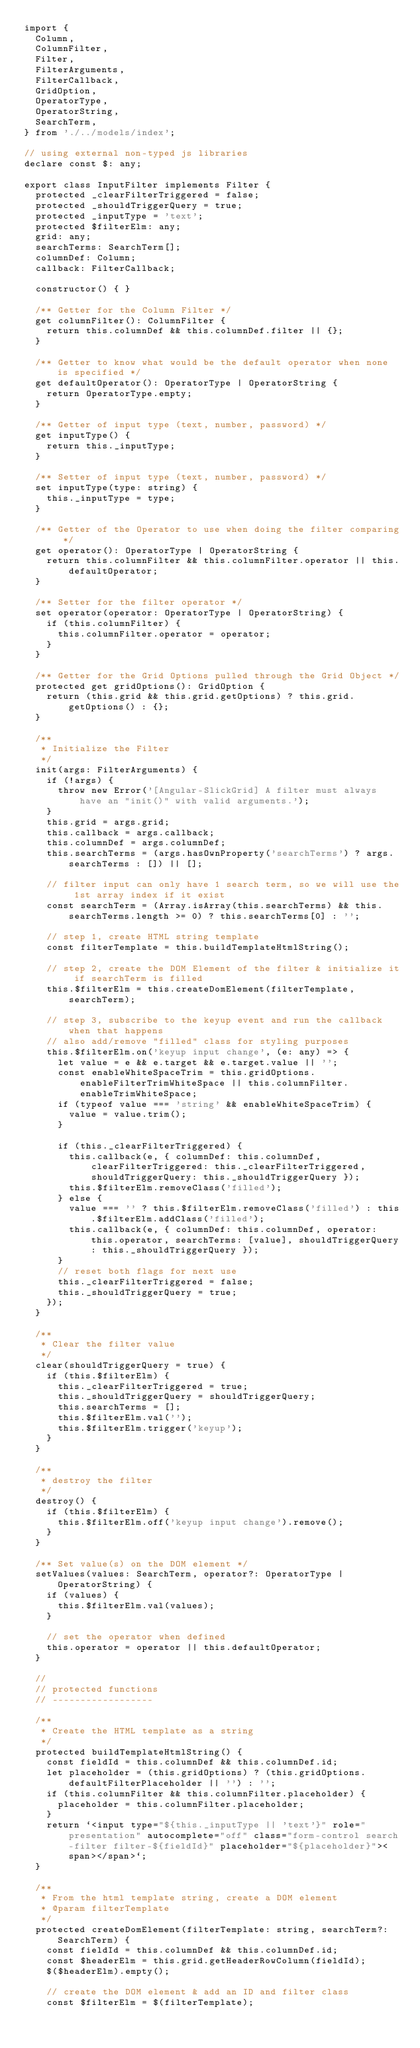<code> <loc_0><loc_0><loc_500><loc_500><_TypeScript_>import {
  Column,
  ColumnFilter,
  Filter,
  FilterArguments,
  FilterCallback,
  GridOption,
  OperatorType,
  OperatorString,
  SearchTerm,
} from './../models/index';

// using external non-typed js libraries
declare const $: any;

export class InputFilter implements Filter {
  protected _clearFilterTriggered = false;
  protected _shouldTriggerQuery = true;
  protected _inputType = 'text';
  protected $filterElm: any;
  grid: any;
  searchTerms: SearchTerm[];
  columnDef: Column;
  callback: FilterCallback;

  constructor() { }

  /** Getter for the Column Filter */
  get columnFilter(): ColumnFilter {
    return this.columnDef && this.columnDef.filter || {};
  }

  /** Getter to know what would be the default operator when none is specified */
  get defaultOperator(): OperatorType | OperatorString {
    return OperatorType.empty;
  }

  /** Getter of input type (text, number, password) */
  get inputType() {
    return this._inputType;
  }

  /** Setter of input type (text, number, password) */
  set inputType(type: string) {
    this._inputType = type;
  }

  /** Getter of the Operator to use when doing the filter comparing */
  get operator(): OperatorType | OperatorString {
    return this.columnFilter && this.columnFilter.operator || this.defaultOperator;
  }

  /** Setter for the filter operator */
  set operator(operator: OperatorType | OperatorString) {
    if (this.columnFilter) {
      this.columnFilter.operator = operator;
    }
  }

  /** Getter for the Grid Options pulled through the Grid Object */
  protected get gridOptions(): GridOption {
    return (this.grid && this.grid.getOptions) ? this.grid.getOptions() : {};
  }

  /**
   * Initialize the Filter
   */
  init(args: FilterArguments) {
    if (!args) {
      throw new Error('[Angular-SlickGrid] A filter must always have an "init()" with valid arguments.');
    }
    this.grid = args.grid;
    this.callback = args.callback;
    this.columnDef = args.columnDef;
    this.searchTerms = (args.hasOwnProperty('searchTerms') ? args.searchTerms : []) || [];

    // filter input can only have 1 search term, so we will use the 1st array index if it exist
    const searchTerm = (Array.isArray(this.searchTerms) && this.searchTerms.length >= 0) ? this.searchTerms[0] : '';

    // step 1, create HTML string template
    const filterTemplate = this.buildTemplateHtmlString();

    // step 2, create the DOM Element of the filter & initialize it if searchTerm is filled
    this.$filterElm = this.createDomElement(filterTemplate, searchTerm);

    // step 3, subscribe to the keyup event and run the callback when that happens
    // also add/remove "filled" class for styling purposes
    this.$filterElm.on('keyup input change', (e: any) => {
      let value = e && e.target && e.target.value || '';
      const enableWhiteSpaceTrim = this.gridOptions.enableFilterTrimWhiteSpace || this.columnFilter.enableTrimWhiteSpace;
      if (typeof value === 'string' && enableWhiteSpaceTrim) {
        value = value.trim();
      }

      if (this._clearFilterTriggered) {
        this.callback(e, { columnDef: this.columnDef, clearFilterTriggered: this._clearFilterTriggered, shouldTriggerQuery: this._shouldTriggerQuery });
        this.$filterElm.removeClass('filled');
      } else {
        value === '' ? this.$filterElm.removeClass('filled') : this.$filterElm.addClass('filled');
        this.callback(e, { columnDef: this.columnDef, operator: this.operator, searchTerms: [value], shouldTriggerQuery: this._shouldTriggerQuery });
      }
      // reset both flags for next use
      this._clearFilterTriggered = false;
      this._shouldTriggerQuery = true;
    });
  }

  /**
   * Clear the filter value
   */
  clear(shouldTriggerQuery = true) {
    if (this.$filterElm) {
      this._clearFilterTriggered = true;
      this._shouldTriggerQuery = shouldTriggerQuery;
      this.searchTerms = [];
      this.$filterElm.val('');
      this.$filterElm.trigger('keyup');
    }
  }

  /**
   * destroy the filter
   */
  destroy() {
    if (this.$filterElm) {
      this.$filterElm.off('keyup input change').remove();
    }
  }

  /** Set value(s) on the DOM element */
  setValues(values: SearchTerm, operator?: OperatorType | OperatorString) {
    if (values) {
      this.$filterElm.val(values);
    }

    // set the operator when defined
    this.operator = operator || this.defaultOperator;
  }

  //
  // protected functions
  // ------------------

  /**
   * Create the HTML template as a string
   */
  protected buildTemplateHtmlString() {
    const fieldId = this.columnDef && this.columnDef.id;
    let placeholder = (this.gridOptions) ? (this.gridOptions.defaultFilterPlaceholder || '') : '';
    if (this.columnFilter && this.columnFilter.placeholder) {
      placeholder = this.columnFilter.placeholder;
    }
    return `<input type="${this._inputType || 'text'}" role="presentation" autocomplete="off" class="form-control search-filter filter-${fieldId}" placeholder="${placeholder}"><span></span>`;
  }

  /**
   * From the html template string, create a DOM element
   * @param filterTemplate
   */
  protected createDomElement(filterTemplate: string, searchTerm?: SearchTerm) {
    const fieldId = this.columnDef && this.columnDef.id;
    const $headerElm = this.grid.getHeaderRowColumn(fieldId);
    $($headerElm).empty();

    // create the DOM element & add an ID and filter class
    const $filterElm = $(filterTemplate);
</code> 